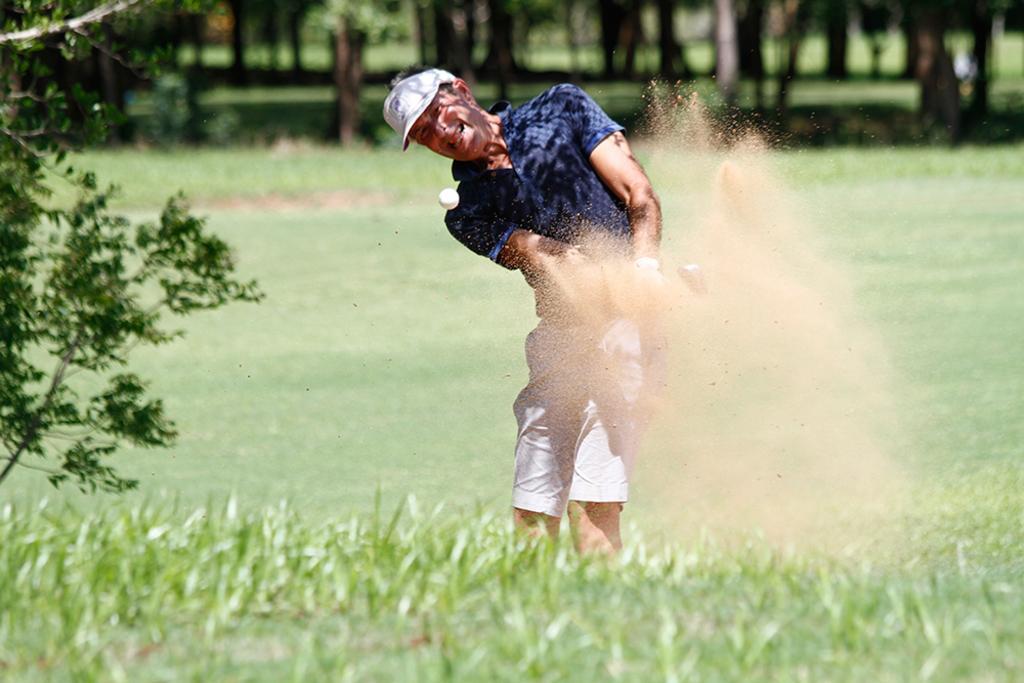In one or two sentences, can you explain what this image depicts? In this image I can see the person wearing the blue and white color dress. I can see the white color ball on the air. To the side of the person I can see the tree and the grass. In the background I can see many trees. 